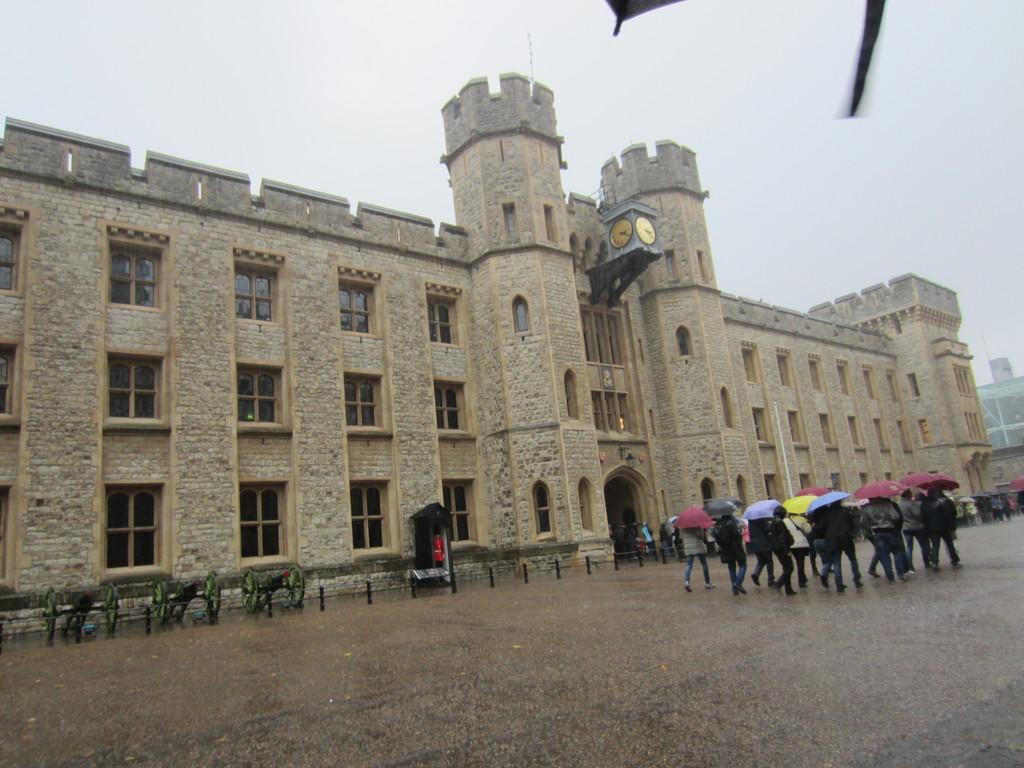In one or two sentences, can you explain what this image depicts? In this image I can see the group of people with different color dresses. I can see these people are holding an umbrellas. To the side of these people I can see the poles and the buildings. In the background I can see the sky. 